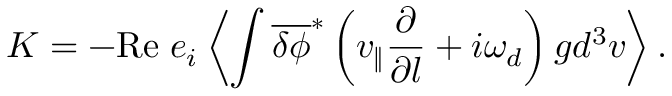Convert formula to latex. <formula><loc_0><loc_0><loc_500><loc_500>K = - R e \, e _ { i } \left \langle \int \overline { \delta \phi } ^ { \ast } \left ( v _ { \| } \frac { \partial } { \partial l } + i \omega _ { d } \right ) g d ^ { 3 } v \right \rangle .</formula> 